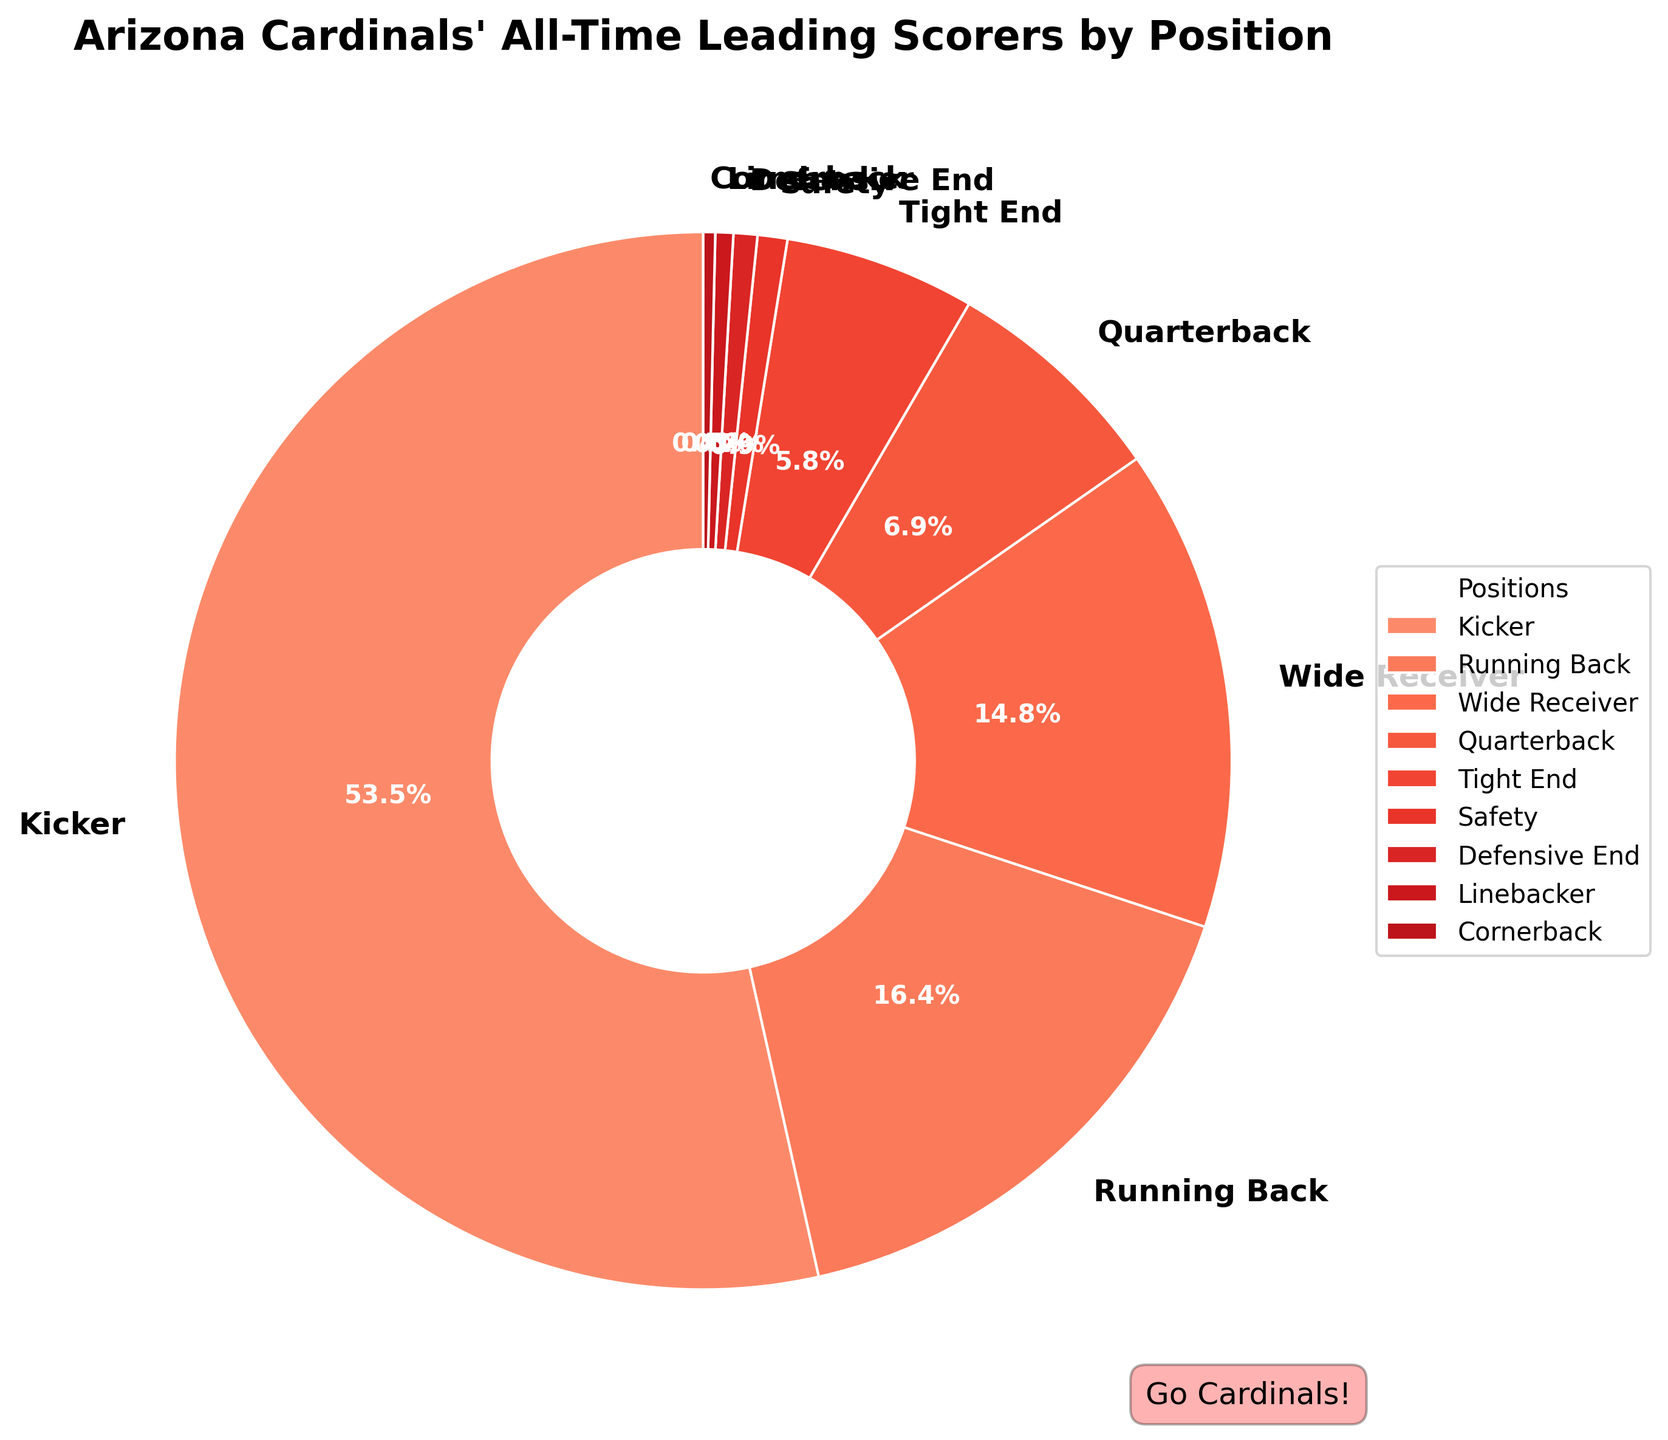Which position contributes the most to the all-time leading scorers for the Arizona Cardinals? The position with the largest section in the pie chart represents the highest contribution. The Kicker has the largest section.
Answer: Kicker What percentage of the total points is contributed by the Running Back and Wide Receiver positions combined? The segments of Running Back and Wide Receiver can be summed. Running Back contributes 540 points, and Wide Receiver contributes 486 points, together accounting for 1026 points. Divide this number by the total points (1761 + 540 + 486 + 228 + 192 + 30 + 24 + 18 + 12 = 3291) and multiply by 100. (1026/3291) * 100 ≈ 31.2%.
Answer: 31.2% Which has a higher contribution to the total points, the Quarterback or the Tight End? Compare the sizes or values for Quarterback and Tight End indicated on the pie chart. The Quarterback contributes 228 points and the Tight End contributes 192 points, so Quarterback has a higher contribution.
Answer: Quarterback How much more does the Kicker contribute to the total score than all defensive positions combined (Safety, Defensive End, Linebacker, Cornerback)? Sum the points of the defensive positions: Safety (30) + Defensive End (24) + Linebacker (18) + Cornerback (12) = 84 points. The Kicker contributes 1761 points. 1761 - 84 = 1677 points.
Answer: 1677 points Which position on the chart has the smallest contribution, and what is its percentage? Determine the smallest section on the pie chart that represents the Cornerback with 12 points. To find its percentage, divide 12 by the total points (3291) and multiply by 100. (12/3291) * 100 ≈ 0.4%.
Answer: Cornerback, 0.4% By how much is the contribution of the Running Back less than the Kicker? Subtract the Running Back’s points from the Kicker’s points: 1761 (Kicker) - 540 (Running Back) = 1221 points.
Answer: 1221 points Compare the contribution of Tight End and Safety. Which one contributes more, and by how much? Tight End contributes 192 points, and Safety contributes 30 points. 192 - 30 = 162 points. Tight End contributes more.
Answer: Tight End, 162 points What percentage of the total points is contributed by the offensive positions (Kicker, Running Back, Wide Receiver, Quarterback, Tight End)? Sum the points for offensive positions: Kicker (1761), Running Back (540), Wide Receiver (486), Quarterback (228), Tight End (192) = 3207 points. Then find the percentage: (3207/3291) * 100 ≈ 97.5%.
Answer: 97.5% How many times greater is the Kicker’s contribution compared to the Wide Receiver? Divide the Kicker's points by Wide Receiver’s points: 1761 (Kicker) / 486 (Wide Receiver) ≈ 3.6.
Answer: 3.6 times 